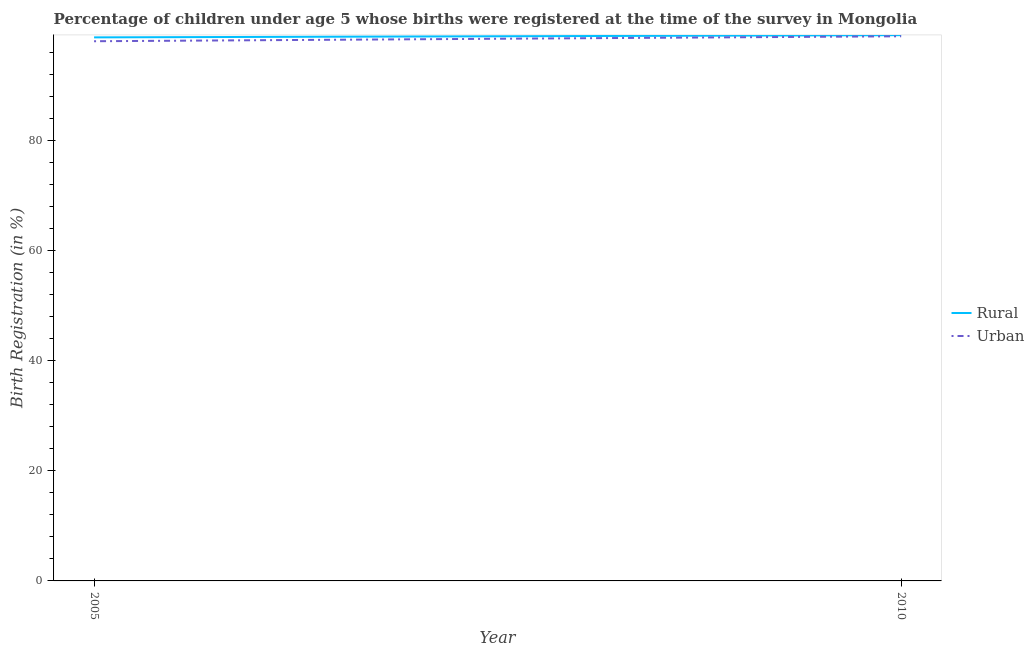What is the urban birth registration in 2005?
Make the answer very short. 98. Across all years, what is the maximum urban birth registration?
Provide a succinct answer. 98.9. Across all years, what is the minimum rural birth registration?
Keep it short and to the point. 98.7. What is the total rural birth registration in the graph?
Ensure brevity in your answer.  197.8. What is the difference between the urban birth registration in 2005 and that in 2010?
Provide a succinct answer. -0.9. What is the difference between the rural birth registration in 2010 and the urban birth registration in 2005?
Offer a very short reply. 1.1. What is the average urban birth registration per year?
Provide a short and direct response. 98.45. In the year 2005, what is the difference between the rural birth registration and urban birth registration?
Ensure brevity in your answer.  0.7. In how many years, is the urban birth registration greater than 44 %?
Provide a succinct answer. 2. What is the ratio of the rural birth registration in 2005 to that in 2010?
Offer a terse response. 1. Is the rural birth registration in 2005 less than that in 2010?
Give a very brief answer. Yes. Does the urban birth registration monotonically increase over the years?
Ensure brevity in your answer.  Yes. Is the urban birth registration strictly greater than the rural birth registration over the years?
Offer a very short reply. No. Is the rural birth registration strictly less than the urban birth registration over the years?
Offer a terse response. No. How many lines are there?
Offer a terse response. 2. How many years are there in the graph?
Give a very brief answer. 2. What is the difference between two consecutive major ticks on the Y-axis?
Ensure brevity in your answer.  20. Does the graph contain any zero values?
Give a very brief answer. No. How are the legend labels stacked?
Offer a terse response. Vertical. What is the title of the graph?
Your answer should be compact. Percentage of children under age 5 whose births were registered at the time of the survey in Mongolia. What is the label or title of the X-axis?
Give a very brief answer. Year. What is the label or title of the Y-axis?
Ensure brevity in your answer.  Birth Registration (in %). What is the Birth Registration (in %) of Rural in 2005?
Give a very brief answer. 98.7. What is the Birth Registration (in %) in Rural in 2010?
Offer a very short reply. 99.1. What is the Birth Registration (in %) of Urban in 2010?
Offer a terse response. 98.9. Across all years, what is the maximum Birth Registration (in %) in Rural?
Offer a very short reply. 99.1. Across all years, what is the maximum Birth Registration (in %) in Urban?
Your answer should be compact. 98.9. Across all years, what is the minimum Birth Registration (in %) in Rural?
Offer a very short reply. 98.7. What is the total Birth Registration (in %) of Rural in the graph?
Make the answer very short. 197.8. What is the total Birth Registration (in %) in Urban in the graph?
Offer a very short reply. 196.9. What is the difference between the Birth Registration (in %) of Urban in 2005 and that in 2010?
Make the answer very short. -0.9. What is the difference between the Birth Registration (in %) in Rural in 2005 and the Birth Registration (in %) in Urban in 2010?
Keep it short and to the point. -0.2. What is the average Birth Registration (in %) in Rural per year?
Give a very brief answer. 98.9. What is the average Birth Registration (in %) of Urban per year?
Your answer should be compact. 98.45. In the year 2010, what is the difference between the Birth Registration (in %) in Rural and Birth Registration (in %) in Urban?
Ensure brevity in your answer.  0.2. What is the ratio of the Birth Registration (in %) in Urban in 2005 to that in 2010?
Provide a succinct answer. 0.99. What is the difference between the highest and the second highest Birth Registration (in %) of Rural?
Offer a terse response. 0.4. What is the difference between the highest and the second highest Birth Registration (in %) in Urban?
Offer a terse response. 0.9. What is the difference between the highest and the lowest Birth Registration (in %) in Rural?
Your response must be concise. 0.4. What is the difference between the highest and the lowest Birth Registration (in %) in Urban?
Give a very brief answer. 0.9. 